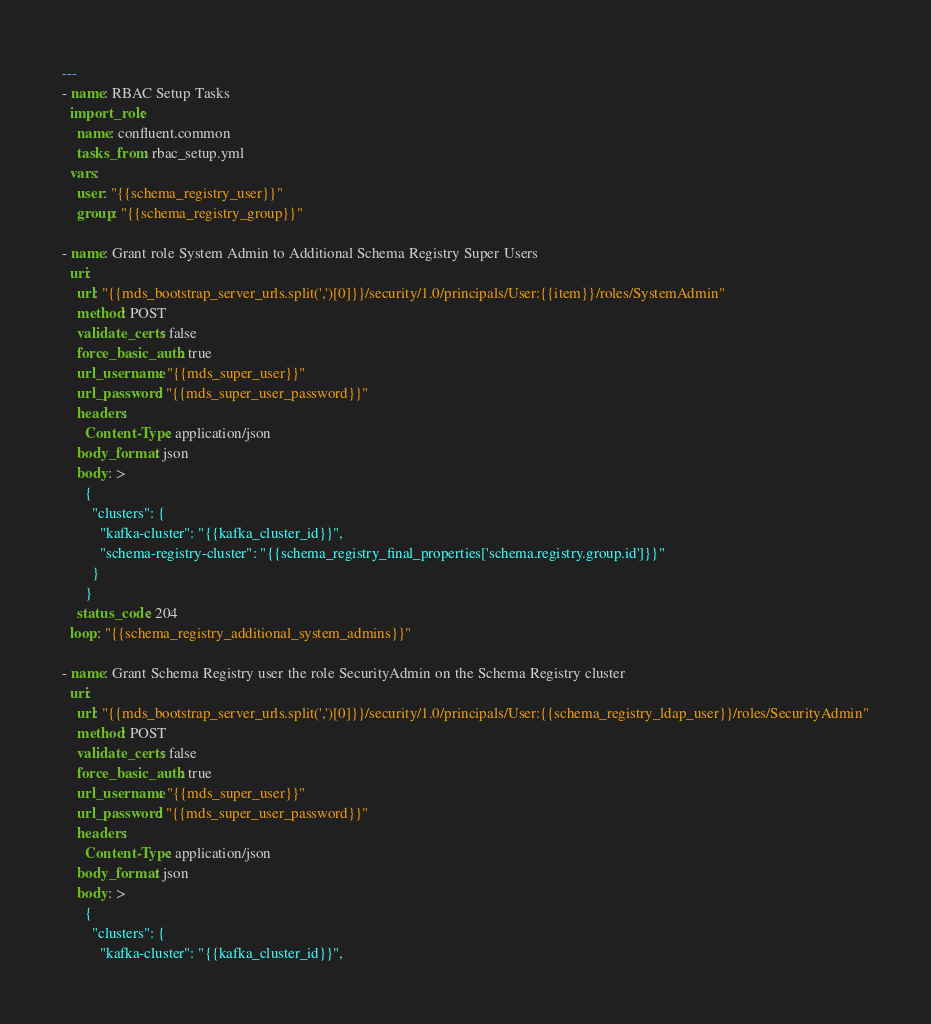Convert code to text. <code><loc_0><loc_0><loc_500><loc_500><_YAML_>---
- name: RBAC Setup Tasks
  import_role:
    name: confluent.common
    tasks_from: rbac_setup.yml
  vars:
    user: "{{schema_registry_user}}"
    group: "{{schema_registry_group}}"

- name: Grant role System Admin to Additional Schema Registry Super Users
  uri:
    url: "{{mds_bootstrap_server_urls.split(',')[0]}}/security/1.0/principals/User:{{item}}/roles/SystemAdmin"
    method: POST
    validate_certs: false
    force_basic_auth: true
    url_username: "{{mds_super_user}}"
    url_password: "{{mds_super_user_password}}"
    headers:
      Content-Type: application/json
    body_format: json
    body: >
      {
        "clusters": {
          "kafka-cluster": "{{kafka_cluster_id}}",
          "schema-registry-cluster": "{{schema_registry_final_properties['schema.registry.group.id']}}"
        }
      }
    status_code: 204
  loop: "{{schema_registry_additional_system_admins}}"

- name: Grant Schema Registry user the role SecurityAdmin on the Schema Registry cluster
  uri:
    url: "{{mds_bootstrap_server_urls.split(',')[0]}}/security/1.0/principals/User:{{schema_registry_ldap_user}}/roles/SecurityAdmin"
    method: POST
    validate_certs: false
    force_basic_auth: true
    url_username: "{{mds_super_user}}"
    url_password: "{{mds_super_user_password}}"
    headers:
      Content-Type: application/json
    body_format: json
    body: >
      {
        "clusters": {
          "kafka-cluster": "{{kafka_cluster_id}}",</code> 